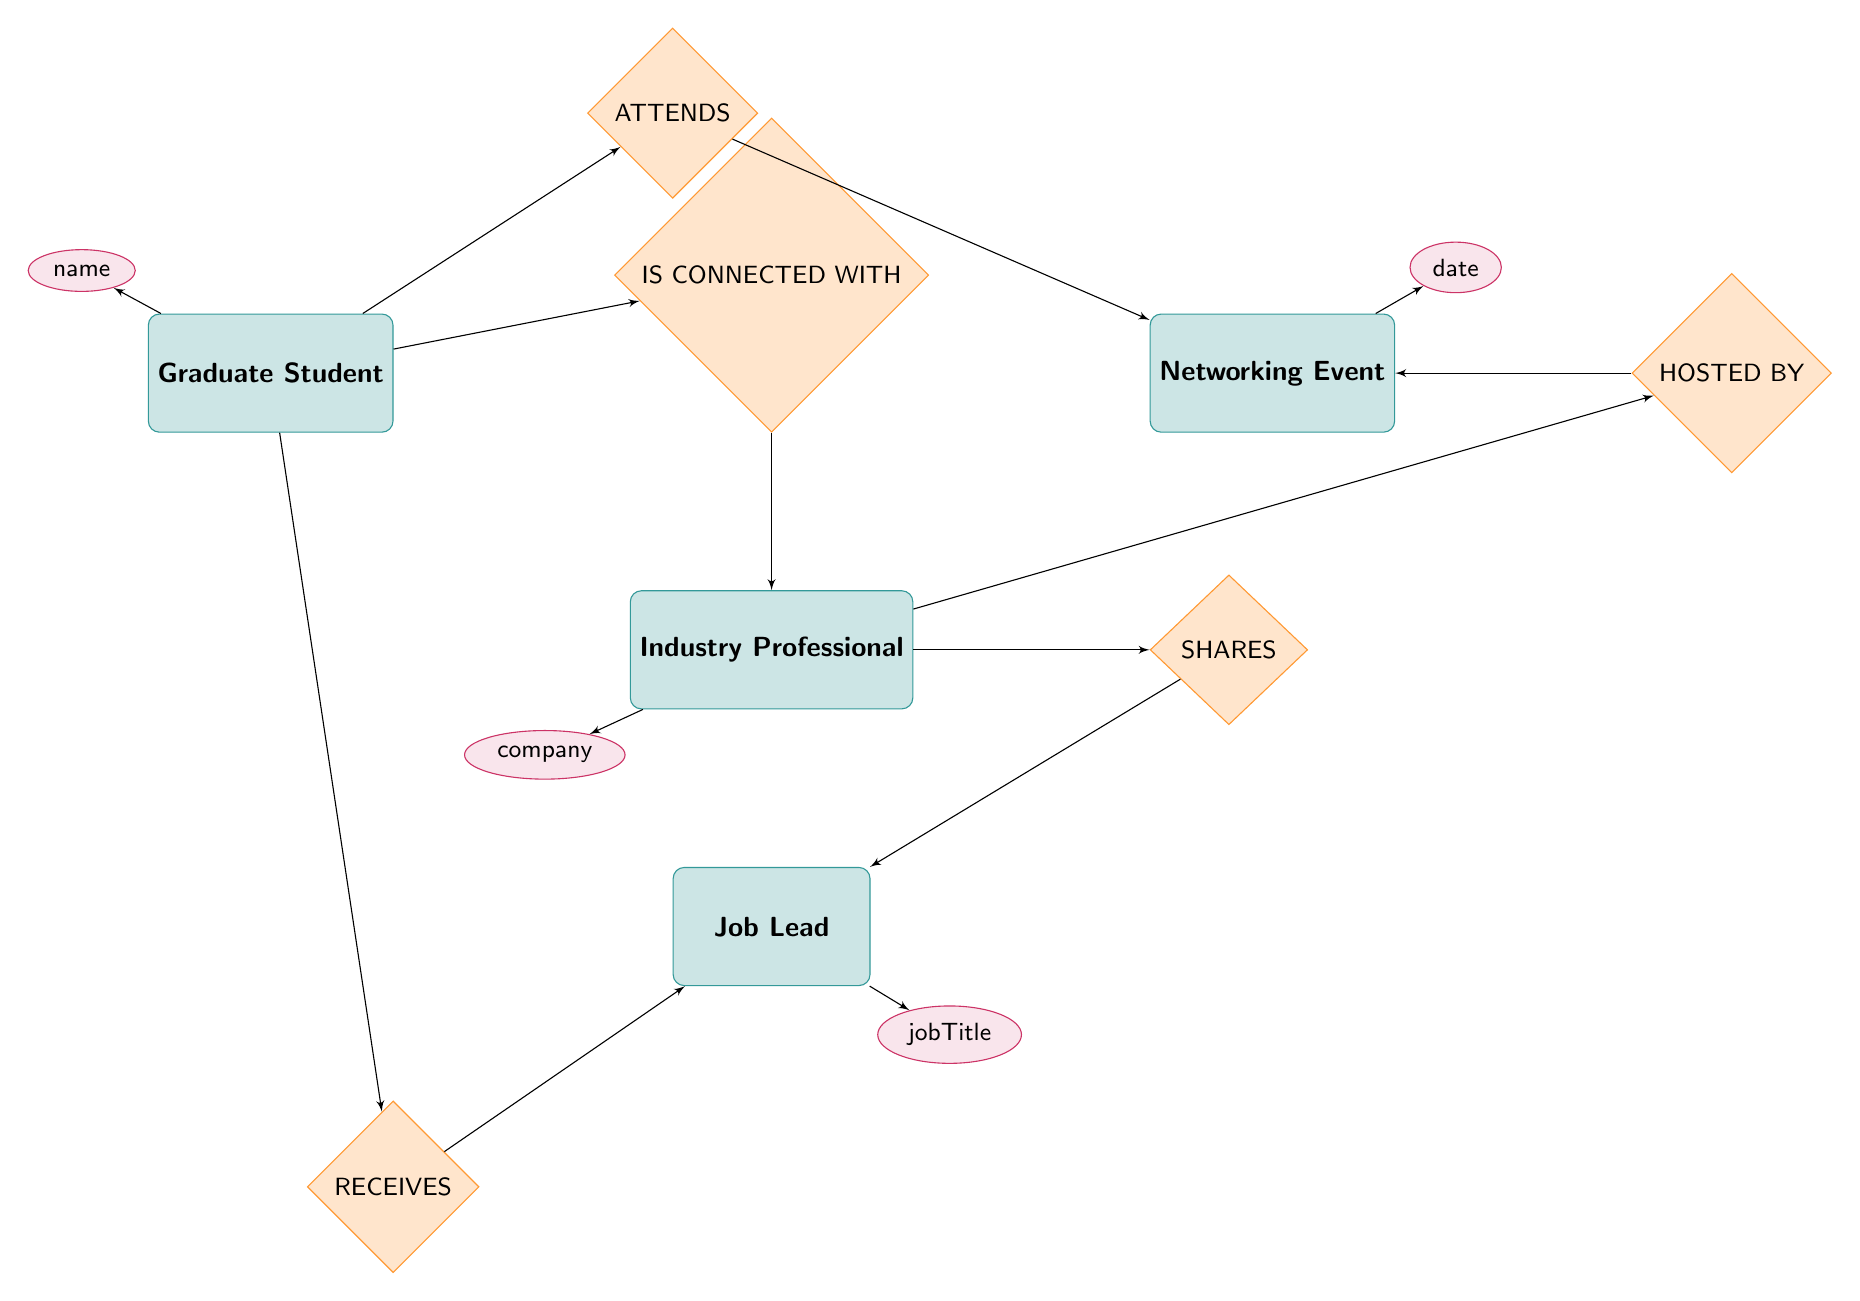What are the entities present in the diagram? The diagram includes four entities: Graduate Student, Industry Professional, Networking Event, and Job Lead.
Answer: Graduate Student, Industry Professional, Networking Event, Job Lead How many relationships are there in the diagram? The diagram shows five relationships: ATTENDS, HOSTED BY, SHARES, RECEIVES, and IS CONNECTED WITH.
Answer: 5 What relationship connects Graduate Student and Networking Event? The relationship connecting Graduate Student and Networking Event is called ATTENDS.
Answer: ATTENDS What attribute is associated with Industry Professional? The attribute associated with Industry Professional is company.
Answer: company What is the relationship between Industry Professional and Job Lead? The relationship between Industry Professional and Job Lead is SHARES.
Answer: SHARES How does a Graduate Student receive Job Leads according to the diagram? According to the diagram, a Graduate Student receives Job Leads through the RECEIVES relationship. This means that there is a flow from Job Lead to Graduate Student via RECEIVES.
Answer: RECEIVES What happens when a Networking Event is hosted by an Industry Professional? When a Networking Event is hosted by an Industry Professional, it indicates the HOSTED BY relationship, meaning the Industry Professional organizes or facilitates the event.
Answer: HOSTED BY When a Graduate Student connects with an Industry Professional, what additional information is provided? The additional information provided includes the connection date, which is represented by the attribute in the IS CONNECTED WITH relationship.
Answer: connectionDate Which entity attends Networking Events? The entity that attends Networking Events is the Graduate Student.
Answer: Graduate Student 